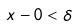Convert formula to latex. <formula><loc_0><loc_0><loc_500><loc_500>x - 0 < \delta</formula> 